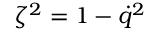<formula> <loc_0><loc_0><loc_500><loc_500>\zeta ^ { 2 } = 1 - \dot { q } ^ { 2 }</formula> 